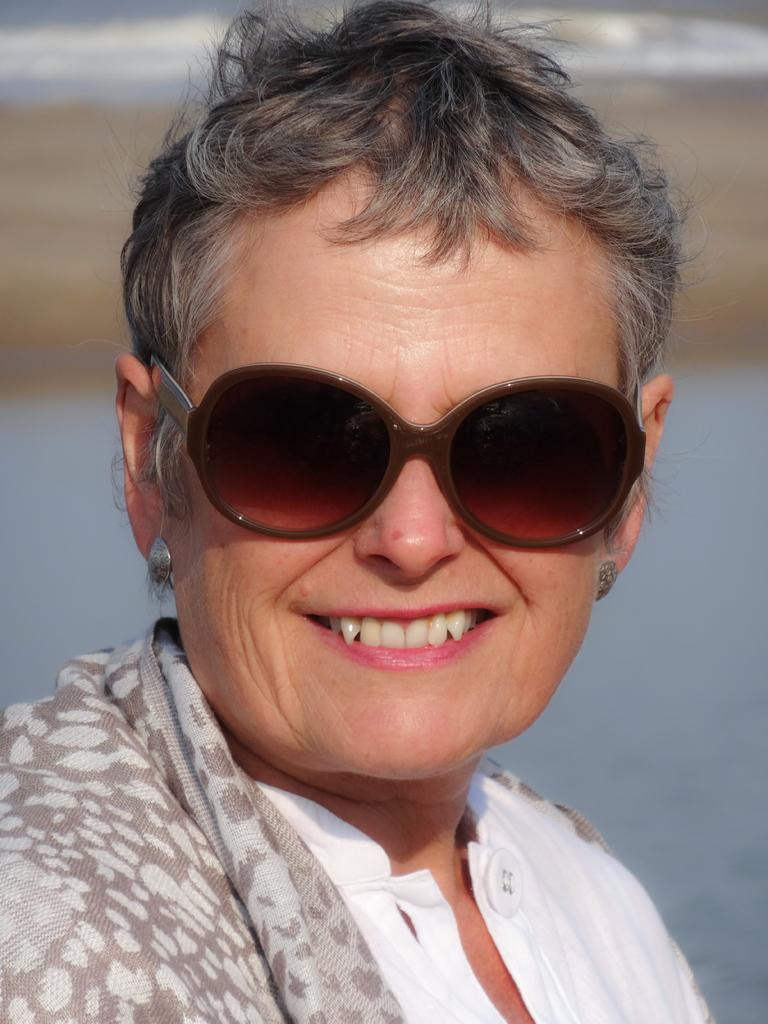Who is the main subject in the image? There is a woman in the image. What is the woman wearing? The woman is wearing a white dress and spectacles. What is the woman's facial expression? The woman is smiling. Can you describe the background of the image? The background of the image is blurred, and there is water visible in it. What decision did the beast make in the image? There is no beast present in the image, so no decision can be attributed to it. 